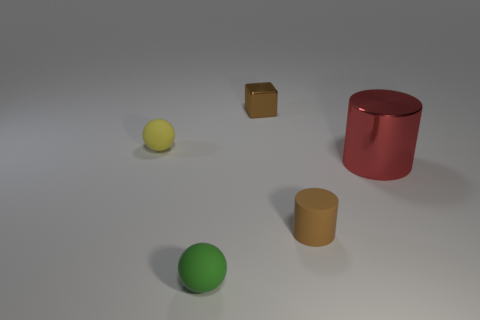Add 4 metal blocks. How many objects exist? 9 Subtract all blocks. How many objects are left? 4 Add 2 metal things. How many metal things are left? 4 Add 3 cylinders. How many cylinders exist? 5 Subtract 0 red cubes. How many objects are left? 5 Subtract all tiny blue metallic blocks. Subtract all tiny metal objects. How many objects are left? 4 